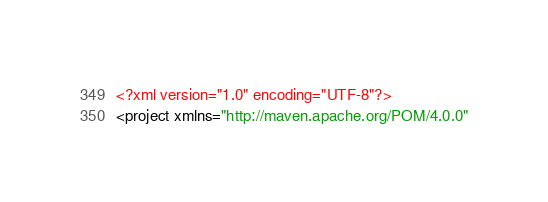Convert code to text. <code><loc_0><loc_0><loc_500><loc_500><_XML_><?xml version="1.0" encoding="UTF-8"?>
<project xmlns="http://maven.apache.org/POM/4.0.0"</code> 